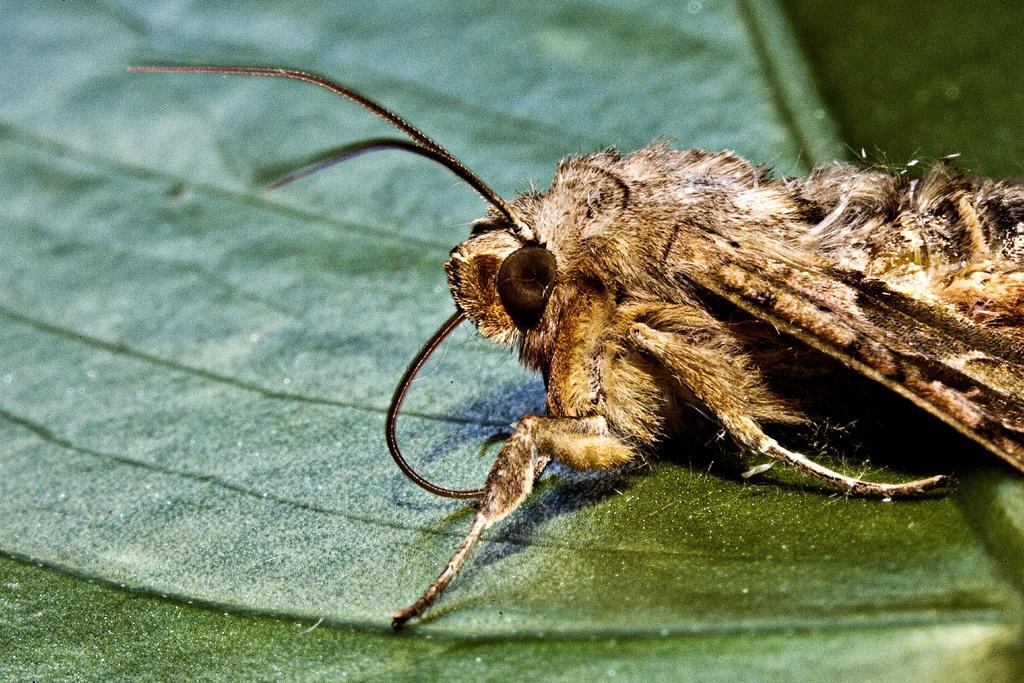Could you give a brief overview of what you see in this image? In this image there is an insect on the leaf. 